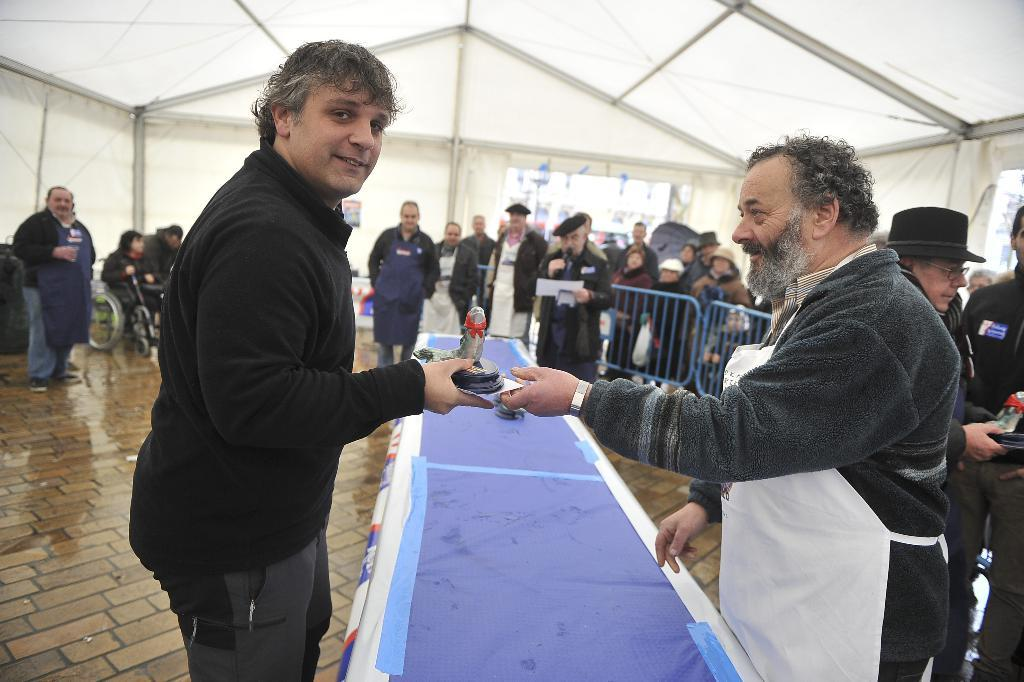What is the person holding in the image? The facts do not specify what the person is holding. Can you describe the setting of the image? There are people visible in the background of the image, and there is a table, a blue color banner, blue color fencing, and a white tent in the image. What color is the banner on the table? The banner on the table is blue. What type of structure is visible in the image? There is a white tent in the image. What type of dog is sitting under the white tent in the image? There is no dog present in the image. 